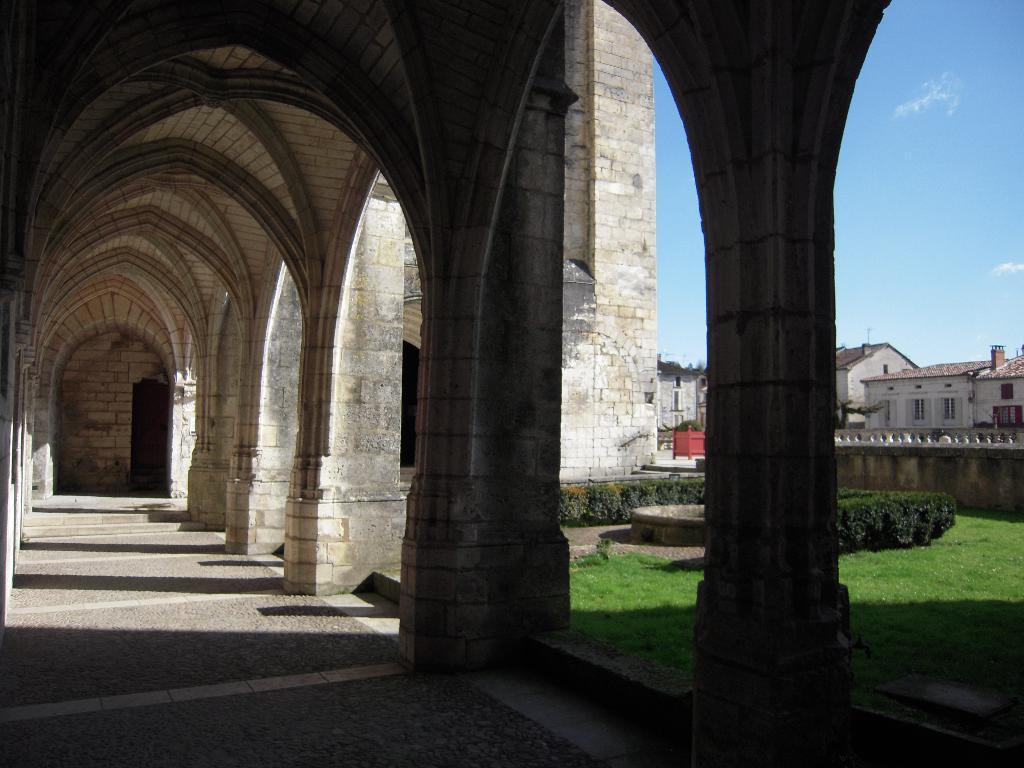What type of structures are present in the image? There are buildings in the image. What can be seen near the buildings? Plants and grass are near the buildings. What is visible in the background of the image? The sky is visible in the background of the image. What type of cake is being rolled out on the grass in the image? There is no cake or rolling action present in the image; it features buildings, plants, grass, and the sky. 